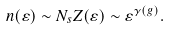Convert formula to latex. <formula><loc_0><loc_0><loc_500><loc_500>n ( \varepsilon ) \sim N _ { s } Z ( \varepsilon ) \sim \varepsilon ^ { \gamma ( g ) } .</formula> 